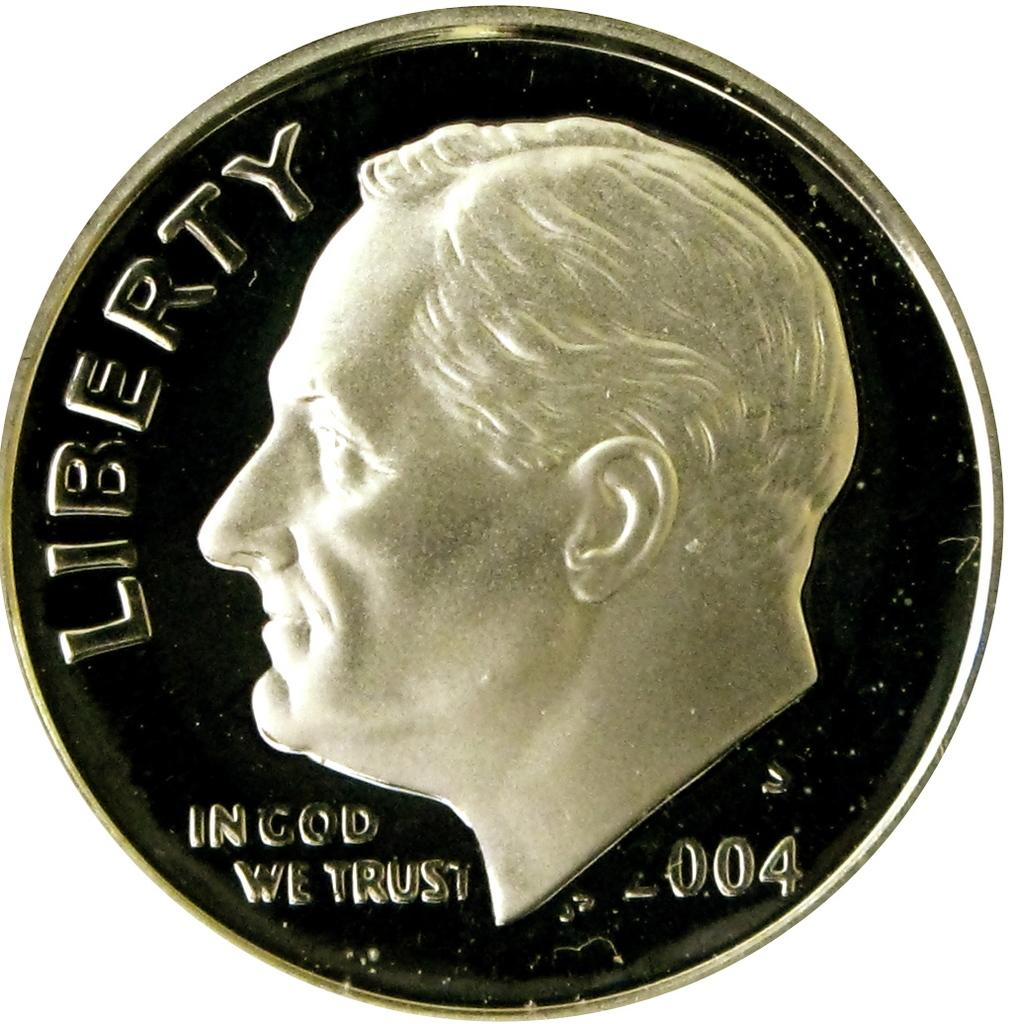<image>
Offer a succinct explanation of the picture presented. A very shiny liberty dime with a year of 2004. 